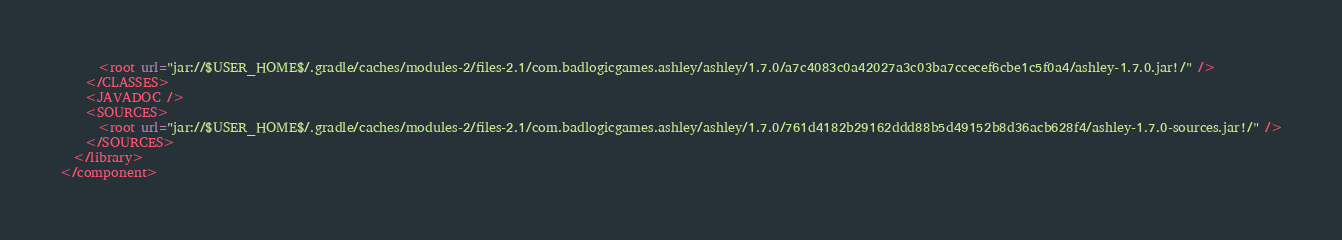Convert code to text. <code><loc_0><loc_0><loc_500><loc_500><_XML_>      <root url="jar://$USER_HOME$/.gradle/caches/modules-2/files-2.1/com.badlogicgames.ashley/ashley/1.7.0/a7c4083c0a42027a3c03ba7ccecef6cbe1c5f0a4/ashley-1.7.0.jar!/" />
    </CLASSES>
    <JAVADOC />
    <SOURCES>
      <root url="jar://$USER_HOME$/.gradle/caches/modules-2/files-2.1/com.badlogicgames.ashley/ashley/1.7.0/761d4182b29162ddd88b5d49152b8d36acb628f4/ashley-1.7.0-sources.jar!/" />
    </SOURCES>
  </library>
</component></code> 